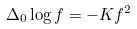<formula> <loc_0><loc_0><loc_500><loc_500>\Delta _ { 0 } \log f = - K f ^ { 2 }</formula> 